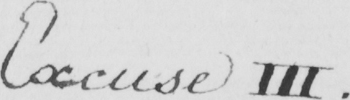What text is written in this handwritten line? Excuse III . 